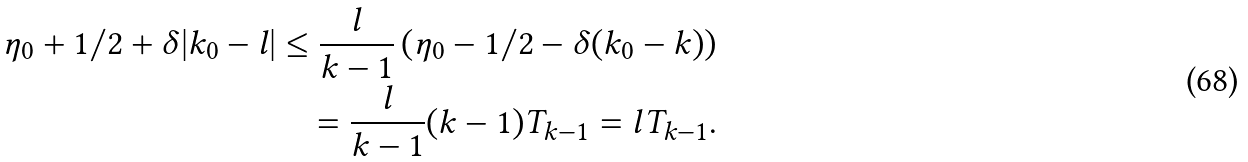Convert formula to latex. <formula><loc_0><loc_0><loc_500><loc_500>\eta _ { 0 } + 1 / 2 + \delta | k _ { 0 } - l | \leq \frac { l } { k - 1 } \left ( \eta _ { 0 } - 1 / 2 - \delta ( k _ { 0 } - k ) \right ) \\ = \frac { l } { k - 1 } ( k - 1 ) T _ { k - 1 } = l T _ { k - 1 } .</formula> 